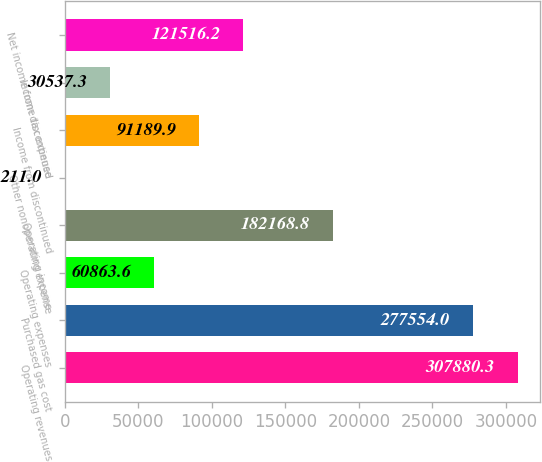Convert chart. <chart><loc_0><loc_0><loc_500><loc_500><bar_chart><fcel>Operating revenues<fcel>Purchased gas cost<fcel>Operating expenses<fcel>Operating income<fcel>Other nonoperating expense<fcel>Income from discontinued<fcel>Income tax expense<fcel>Net income from discontinued<nl><fcel>307880<fcel>277554<fcel>60863.6<fcel>182169<fcel>211<fcel>91189.9<fcel>30537.3<fcel>121516<nl></chart> 